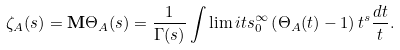Convert formula to latex. <formula><loc_0><loc_0><loc_500><loc_500>\zeta _ { A } ( s ) = { \mathbf M } \Theta _ { A } ( s ) = \frac { 1 } { \Gamma ( s ) } \int \lim i t s _ { 0 } ^ { \infty } \left ( \Theta _ { A } ( t ) - 1 \right ) t ^ { s } \frac { d t } { t } .</formula> 